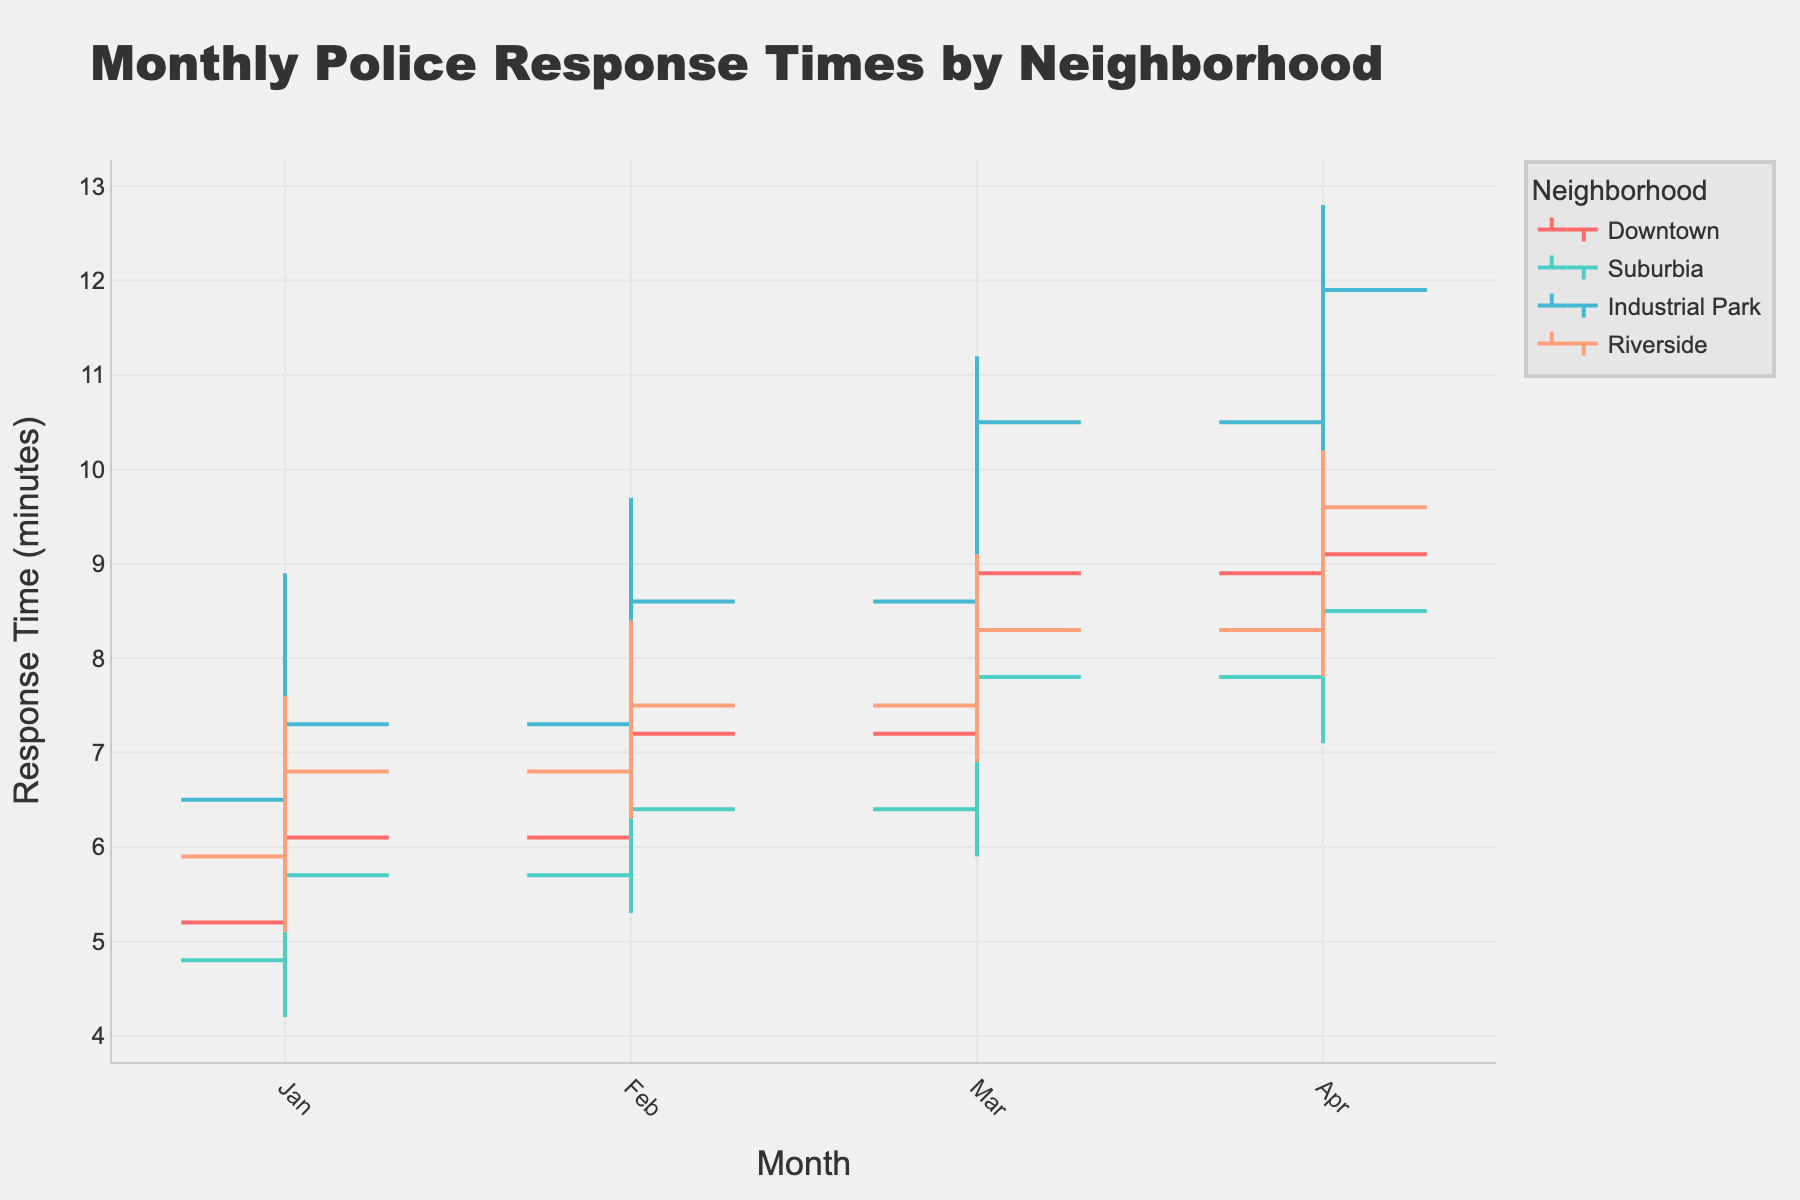Does the chart show the response times for different neighborhoods or one specific neighborhood? The chart's title indicates that it shows monthly police response times for different neighborhoods. Additionally, the legend shows multiple neighborhoods such as Downtown, Suburbia, Industrial Park, and Riverside, each with its own color.
Answer: Different neighborhoods What is the highest police response time recorded in Downtown across all months? By looking at the 'High' value of the OHLC chart for Downtown, the highest response time recorded is in April with a 'High' value of 10.2 minutes.
Answer: 10.2 minutes Which neighborhood had the most consistent police response times, judged by the narrowest range between high and low values? For each neighborhood, find the difference between the high and low values for each month, and then average them across the months. Suburbia has the smallest fluctuations, indicating more consistent response times.
Answer: Suburbia In which month did the Industrial Park experience the highest minimum police response time, and what was it? By checking the 'Low' value for Industrial Park across the months, March had the highest minimum time with a value of 8.1 minutes.
Answer: March, 8.1 minutes What was the difference in closing police response times between March and April for Riverside? Riverside's closing police response time in March is 8.3 minutes and in April is 9.6 minutes. The difference is 9.6 - 8.3 = 1.3 minutes.
Answer: 1.3 minutes Which neighborhood showed the largest increase in closing police response times from January to February? Comparing the closing values from January to February for each neighborhood, Downtown had the largest increase, from 6.1 to 7.2 minutes, which is an increase of 1.1 minutes.
Answer: Downtown How did Downtown's police response time trend over the months? Downtown's closing values indicate an upward trend: January (6.1), February (7.2), March (8.9), and April (9.1). The response time increased each month.
Answer: Upward trend Which neighborhood has the highest variance in response times over the observed months? By examining the ranges for each neighborhood, Industrial Park shows the highest variance with the largest differences between "Low" and "High" across different months, particularly in March and April.
Answer: Industrial Park What is the range of police response times for Suburbia in February? Suburbia's February 'High' value is 7.1 minutes and 'Low' value is 5.3 minutes. The range is 7.1 - 5.3 = 1.8 minutes.
Answer: 1.8 minutes Across all months, which neighborhood generally had the highest average 'Open' response time? Calculate the average 'Open' values for each neighborhood: Downtown (5.2, 6.1, 7.2, 8.9), Suburbia (4.8, 5.7, 6.4, 7.8), Industrial Park (6.5, 7.3, 8.6, 10.5), Riverside (5.9, 6.8, 7.5, 8.3). Industrial Park has the highest average 'Open' value.
Answer: Industrial Park 